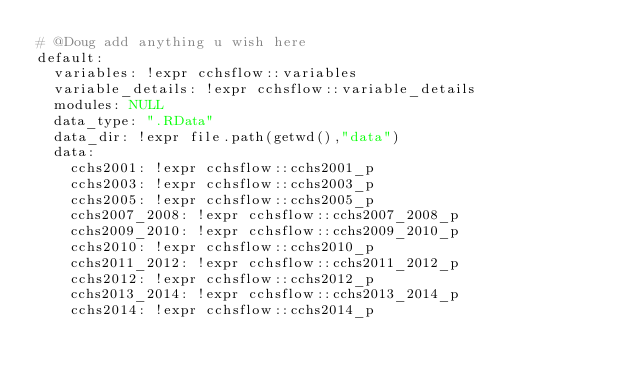<code> <loc_0><loc_0><loc_500><loc_500><_YAML_># @Doug add anything u wish here
default:
  variables: !expr cchsflow::variables
  variable_details: !expr cchsflow::variable_details
  modules: NULL
  data_type: ".RData"
  data_dir: !expr file.path(getwd(),"data")
  data:
    cchs2001: !expr cchsflow::cchs2001_p
    cchs2003: !expr cchsflow::cchs2003_p
    cchs2005: !expr cchsflow::cchs2005_p
    cchs2007_2008: !expr cchsflow::cchs2007_2008_p
    cchs2009_2010: !expr cchsflow::cchs2009_2010_p
    cchs2010: !expr cchsflow::cchs2010_p
    cchs2011_2012: !expr cchsflow::cchs2011_2012_p
    cchs2012: !expr cchsflow::cchs2012_p
    cchs2013_2014: !expr cchsflow::cchs2013_2014_p
    cchs2014: !expr cchsflow::cchs2014_p
</code> 